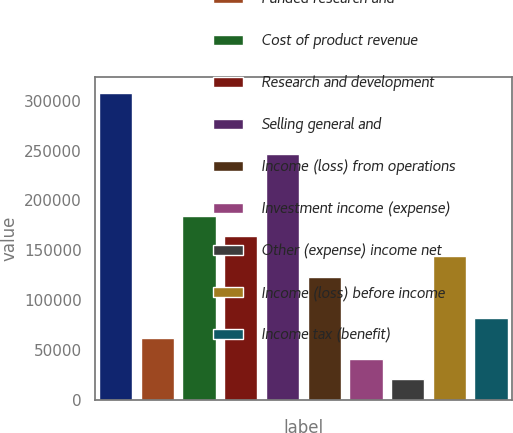<chart> <loc_0><loc_0><loc_500><loc_500><bar_chart><fcel>Products<fcel>Funded research and<fcel>Cost of product revenue<fcel>Research and development<fcel>Selling general and<fcel>Income (loss) from operations<fcel>Investment income (expense)<fcel>Other (expense) income net<fcel>Income (loss) before income<fcel>Income tax (benefit)<nl><fcel>308110<fcel>61622.2<fcel>184866<fcel>164326<fcel>246488<fcel>123244<fcel>41081.6<fcel>20540.9<fcel>143785<fcel>82162.9<nl></chart> 